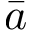Convert formula to latex. <formula><loc_0><loc_0><loc_500><loc_500>\bar { a }</formula> 